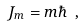<formula> <loc_0><loc_0><loc_500><loc_500>J _ { m } = m \hbar { \ } ,</formula> 